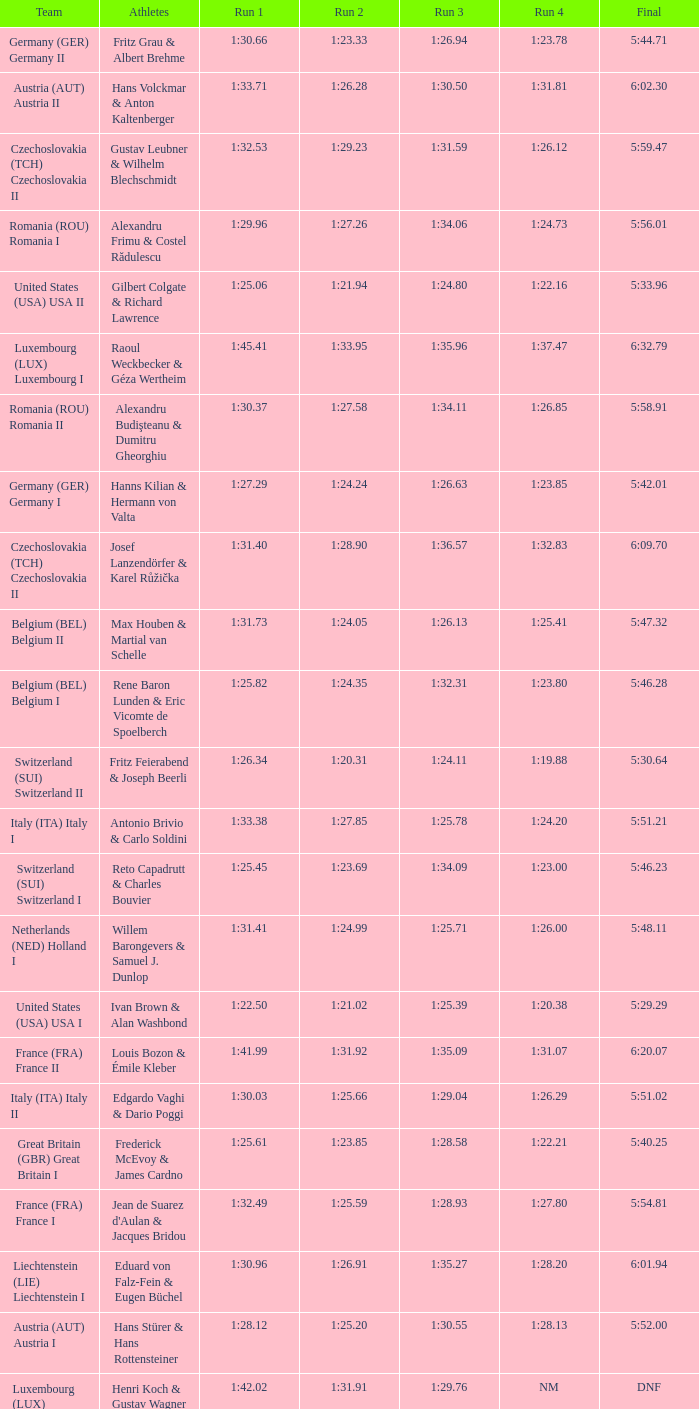Which Run 4 has a Run 3 of 1:26.63? 1:23.85. 